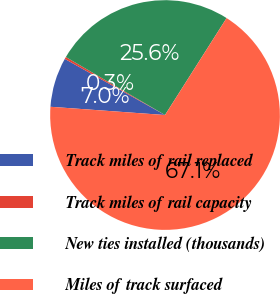Convert chart to OTSL. <chart><loc_0><loc_0><loc_500><loc_500><pie_chart><fcel>Track miles of rail replaced<fcel>Track miles of rail capacity<fcel>New ties installed (thousands)<fcel>Miles of track surfaced<nl><fcel>6.98%<fcel>0.3%<fcel>25.58%<fcel>67.14%<nl></chart> 